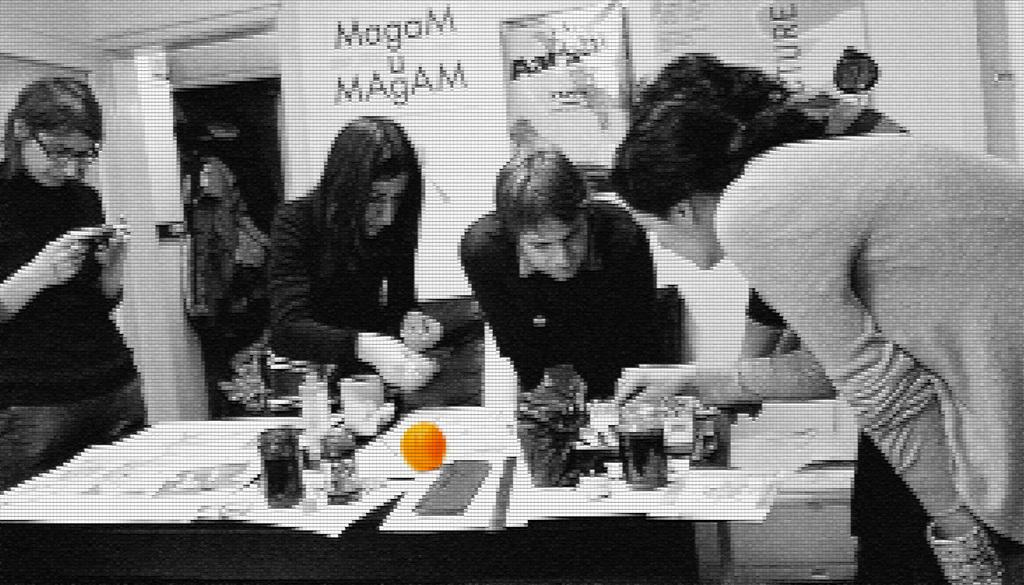What is the main subject of the image? The main subject of the image is a group of women. What are the women doing in the image? The women are doing something on a table. What type of chin can be seen on the table in the image? There is no chin present on the table in the image. What type of battle is depicted in the image? There is no battle depicted in the image; it features a group of women working on a table. 